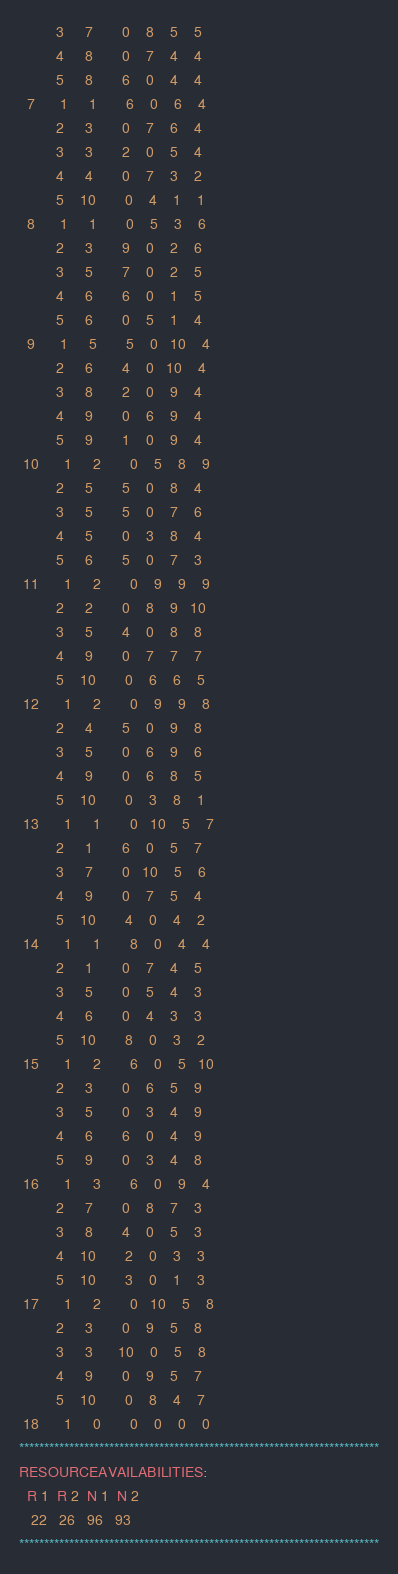<code> <loc_0><loc_0><loc_500><loc_500><_ObjectiveC_>         3     7       0    8    5    5
         4     8       0    7    4    4
         5     8       6    0    4    4
  7      1     1       6    0    6    4
         2     3       0    7    6    4
         3     3       2    0    5    4
         4     4       0    7    3    2
         5    10       0    4    1    1
  8      1     1       0    5    3    6
         2     3       9    0    2    6
         3     5       7    0    2    5
         4     6       6    0    1    5
         5     6       0    5    1    4
  9      1     5       5    0   10    4
         2     6       4    0   10    4
         3     8       2    0    9    4
         4     9       0    6    9    4
         5     9       1    0    9    4
 10      1     2       0    5    8    9
         2     5       5    0    8    4
         3     5       5    0    7    6
         4     5       0    3    8    4
         5     6       5    0    7    3
 11      1     2       0    9    9    9
         2     2       0    8    9   10
         3     5       4    0    8    8
         4     9       0    7    7    7
         5    10       0    6    6    5
 12      1     2       0    9    9    8
         2     4       5    0    9    8
         3     5       0    6    9    6
         4     9       0    6    8    5
         5    10       0    3    8    1
 13      1     1       0   10    5    7
         2     1       6    0    5    7
         3     7       0   10    5    6
         4     9       0    7    5    4
         5    10       4    0    4    2
 14      1     1       8    0    4    4
         2     1       0    7    4    5
         3     5       0    5    4    3
         4     6       0    4    3    3
         5    10       8    0    3    2
 15      1     2       6    0    5   10
         2     3       0    6    5    9
         3     5       0    3    4    9
         4     6       6    0    4    9
         5     9       0    3    4    8
 16      1     3       6    0    9    4
         2     7       0    8    7    3
         3     8       4    0    5    3
         4    10       2    0    3    3
         5    10       3    0    1    3
 17      1     2       0   10    5    8
         2     3       0    9    5    8
         3     3      10    0    5    8
         4     9       0    9    5    7
         5    10       0    8    4    7
 18      1     0       0    0    0    0
************************************************************************
RESOURCEAVAILABILITIES:
  R 1  R 2  N 1  N 2
   22   26   96   93
************************************************************************
</code> 